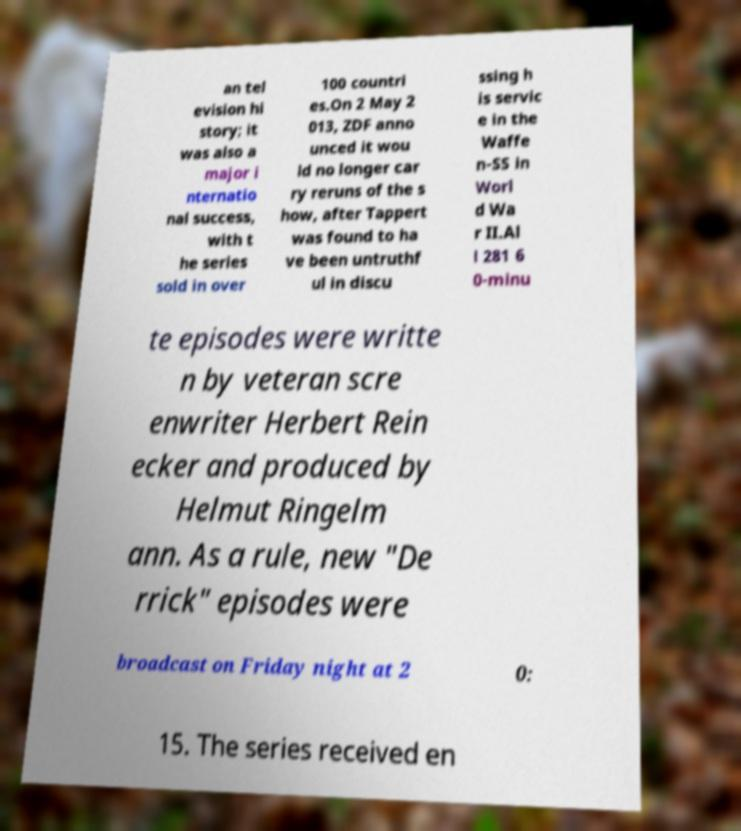There's text embedded in this image that I need extracted. Can you transcribe it verbatim? an tel evision hi story; it was also a major i nternatio nal success, with t he series sold in over 100 countri es.On 2 May 2 013, ZDF anno unced it wou ld no longer car ry reruns of the s how, after Tappert was found to ha ve been untruthf ul in discu ssing h is servic e in the Waffe n-SS in Worl d Wa r II.Al l 281 6 0-minu te episodes were writte n by veteran scre enwriter Herbert Rein ecker and produced by Helmut Ringelm ann. As a rule, new "De rrick" episodes were broadcast on Friday night at 2 0: 15. The series received en 